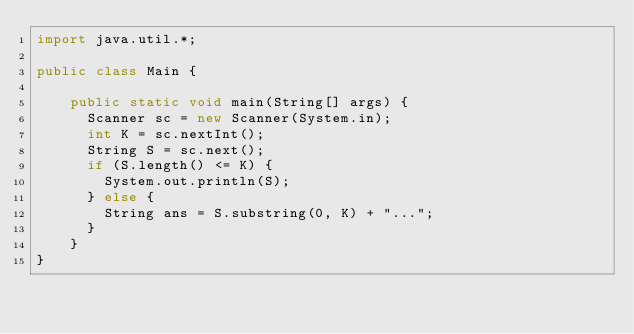<code> <loc_0><loc_0><loc_500><loc_500><_Java_>import java.util.*;
 
public class Main {
	
    public static void main(String[] args) {
    	Scanner sc = new Scanner(System.in);
    	int K = sc.nextInt();
    	String S = sc.next();
    	if (S.length() <= K) {
    		System.out.println(S);
    	} else {
    		String ans = S.substring(0, K) + "...";
    	}
    }
}</code> 